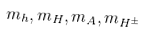Convert formula to latex. <formula><loc_0><loc_0><loc_500><loc_500>m _ { h } , m _ { H } , m _ { A } , m _ { H ^ { \pm } }</formula> 